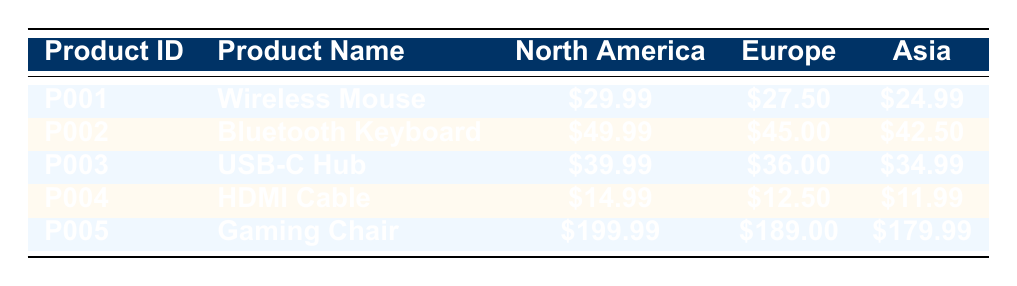What is the price of the Wireless Mouse in Europe? The price for the Wireless Mouse in Europe is listed in the table under the corresponding region and product. Specifically, it shows a price of 27.50.
Answer: 27.50 Which product has the lowest price in Asia? By examining the prices in the Asia column for all products, the lowest price is for the HDMI Cable, which is 11.99.
Answer: HDMI Cable What is the total price of the Bluetooth Keyboard in all regions? To calculate the total price of the Bluetooth Keyboard, we sum the prices: 49.99 (North America) + 45.00 (Europe) + 42.50 (Asia) = 137.49.
Answer: 137.49 Is the price of the USB-C Hub higher in North America than in Europe? The price of the USB-C Hub in North America is 39.99, while in Europe it is 36.00. Since 39.99 is greater than 36.00, the statement is true.
Answer: Yes What is the average price of the Gaming Chair across all regions? The average price of the Gaming Chair is calculated by summing all regional prices: 199.99 (North America) + 189.00 (Europe) + 179.99 (Asia) = 568.98 and dividing by 3 gives 568.98 / 3 = 189.66.
Answer: 189.66 Which product is the most expensive in North America? By comparing the prices in the North America column, the Gaming Chair has the highest price at 199.99, making it the most expensive product in that region.
Answer: Gaming Chair Does the Bluetooth Keyboard have a higher price in Europe than the Wireless Mouse in North America? The price of the Bluetooth Keyboard in Europe is 45.00, while the price of the Wireless Mouse in North America is 29.99. Since 45.00 is greater than 29.99, the statement is true.
Answer: Yes Find the price difference of the HDMI Cable between North America and Asia. To find the price difference, we subtract the price in Asia from the price in North America: 14.99 (North America) - 11.99 (Asia) = 3.00.
Answer: 3.00 